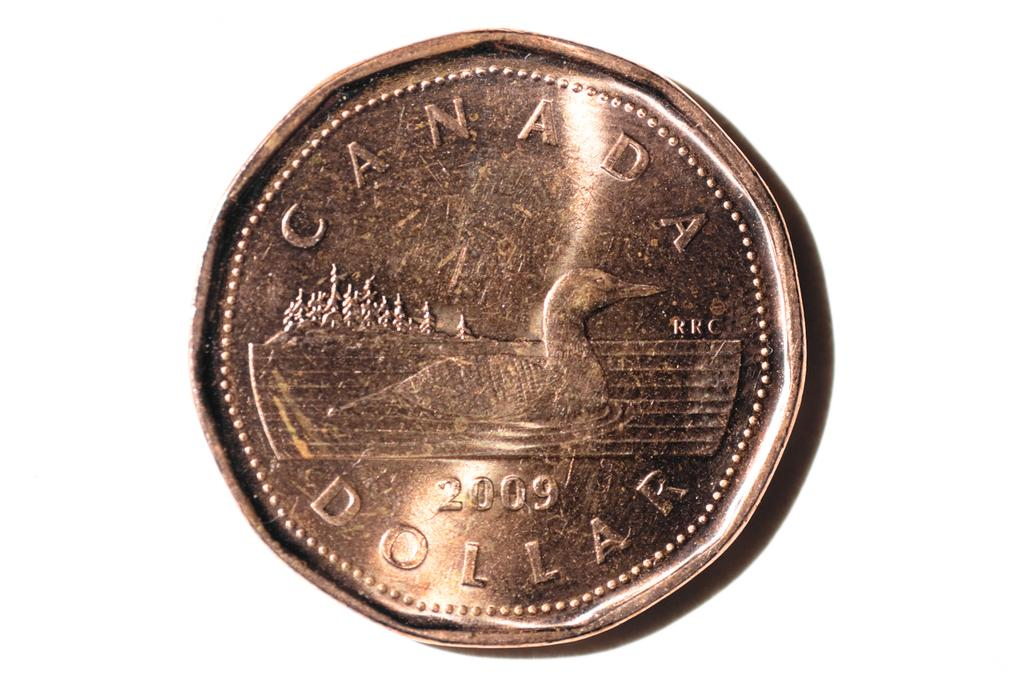What object is the main focus of the image? The main focus of the image is a coin. What can be found on the surface of the coin? The coin has text and an image of a bird on it. Are there any numbers present on the coin? Yes, there are numbers on the coin. What is the color of the background on the coin? The background of the coin is white. How many sheep can be seen grazing in the background of the image? There are no sheep present in the image; it features a coin with text, an image of a bird, numbers, and a white background. 